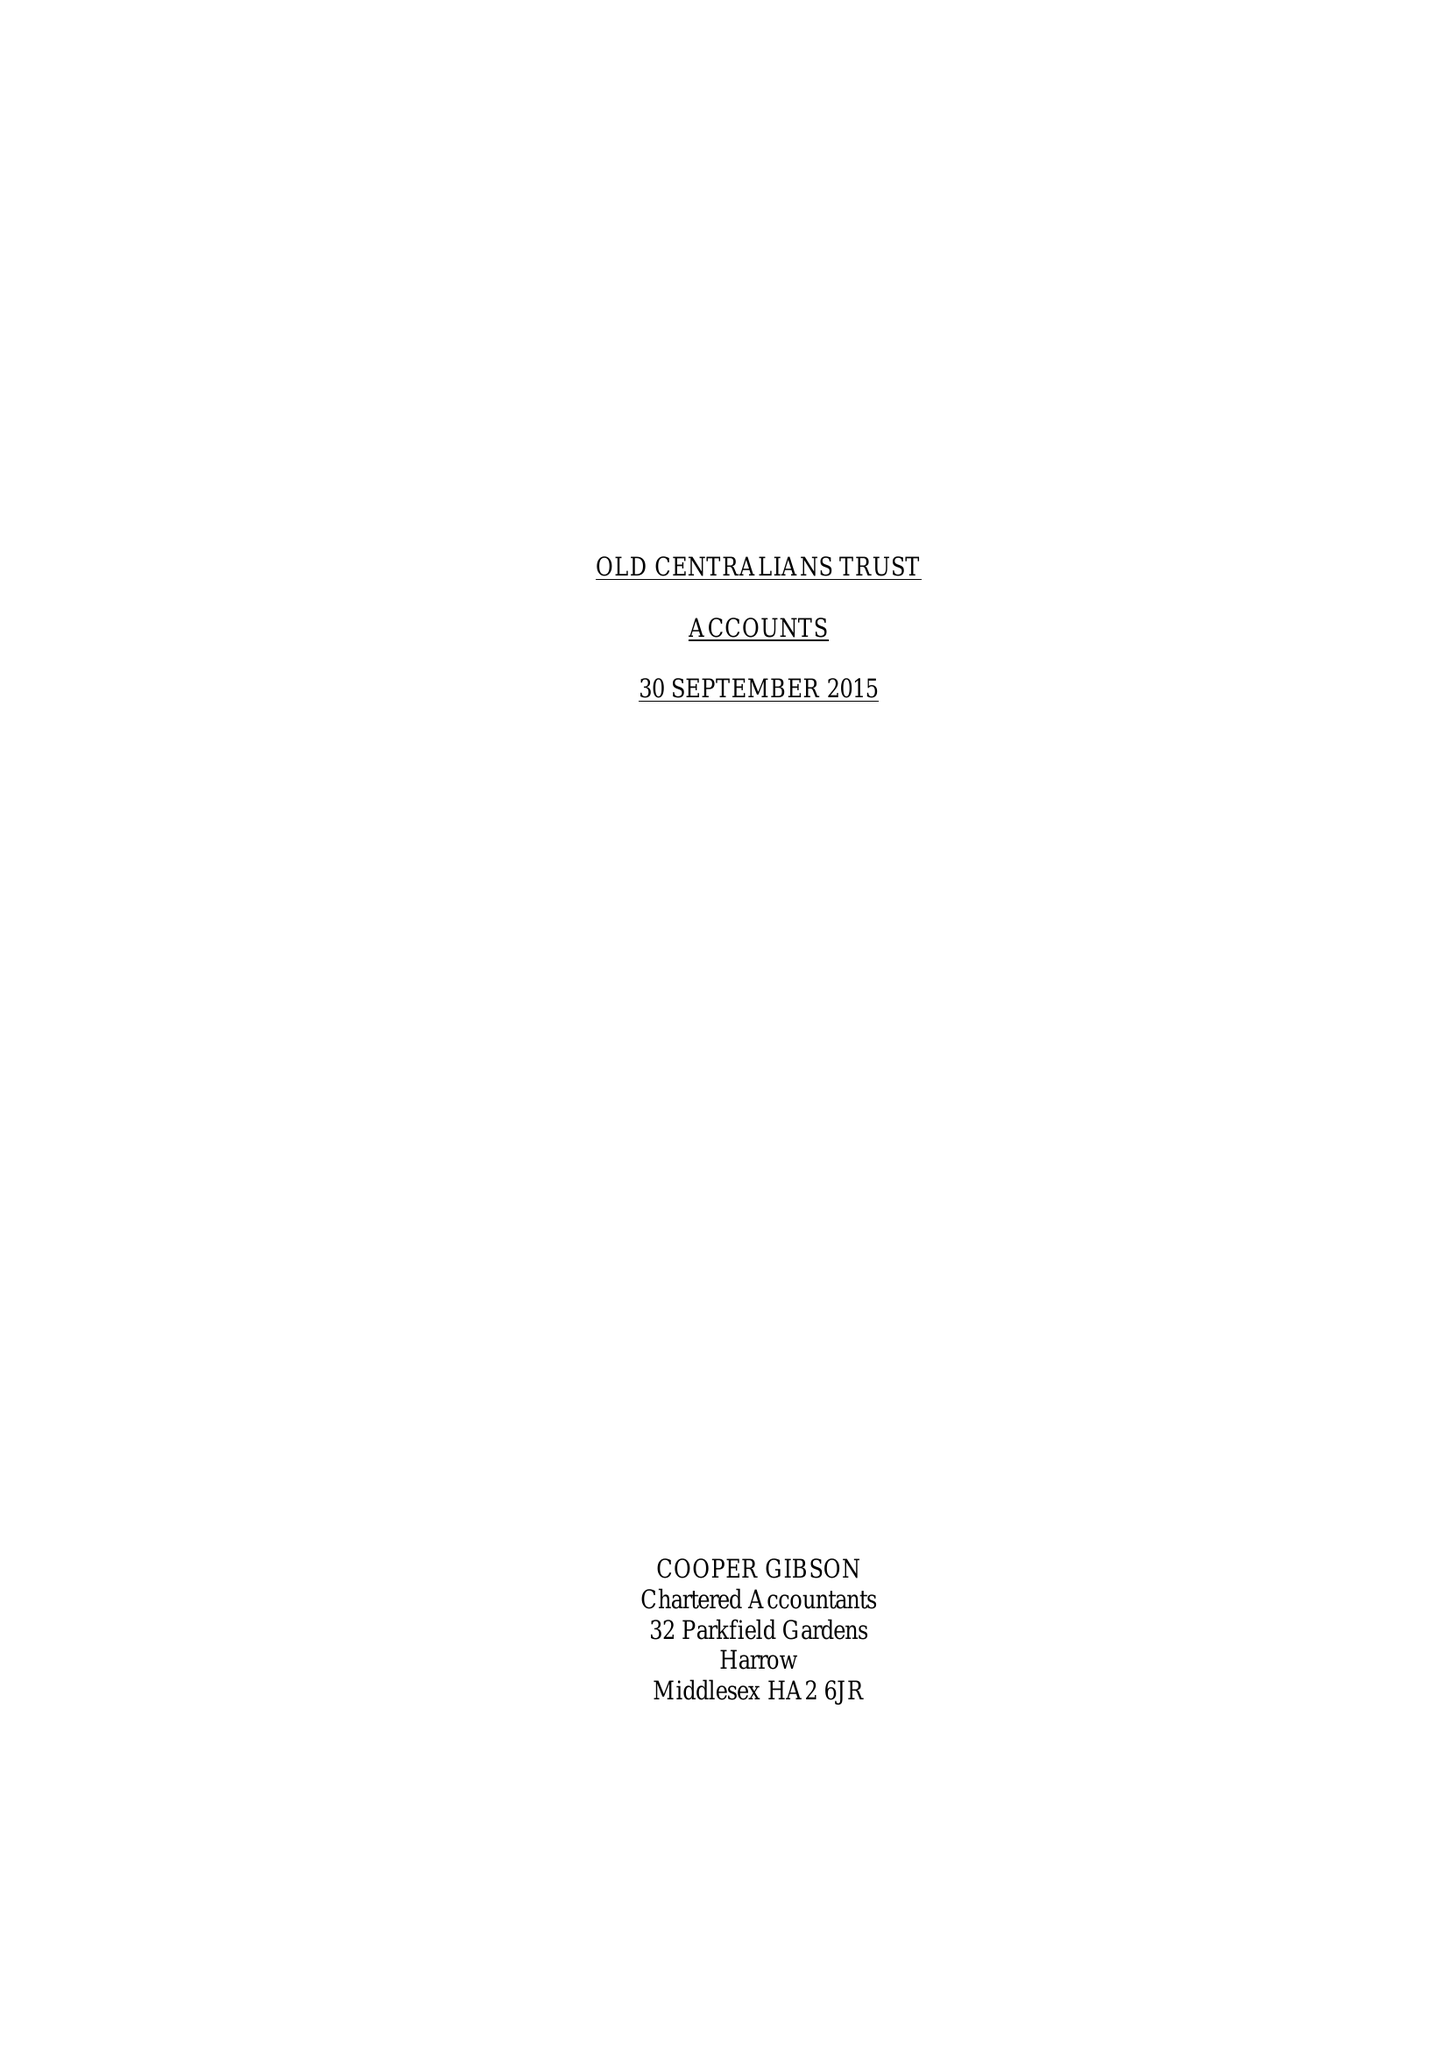What is the value for the report_date?
Answer the question using a single word or phrase. 2015-09-30 